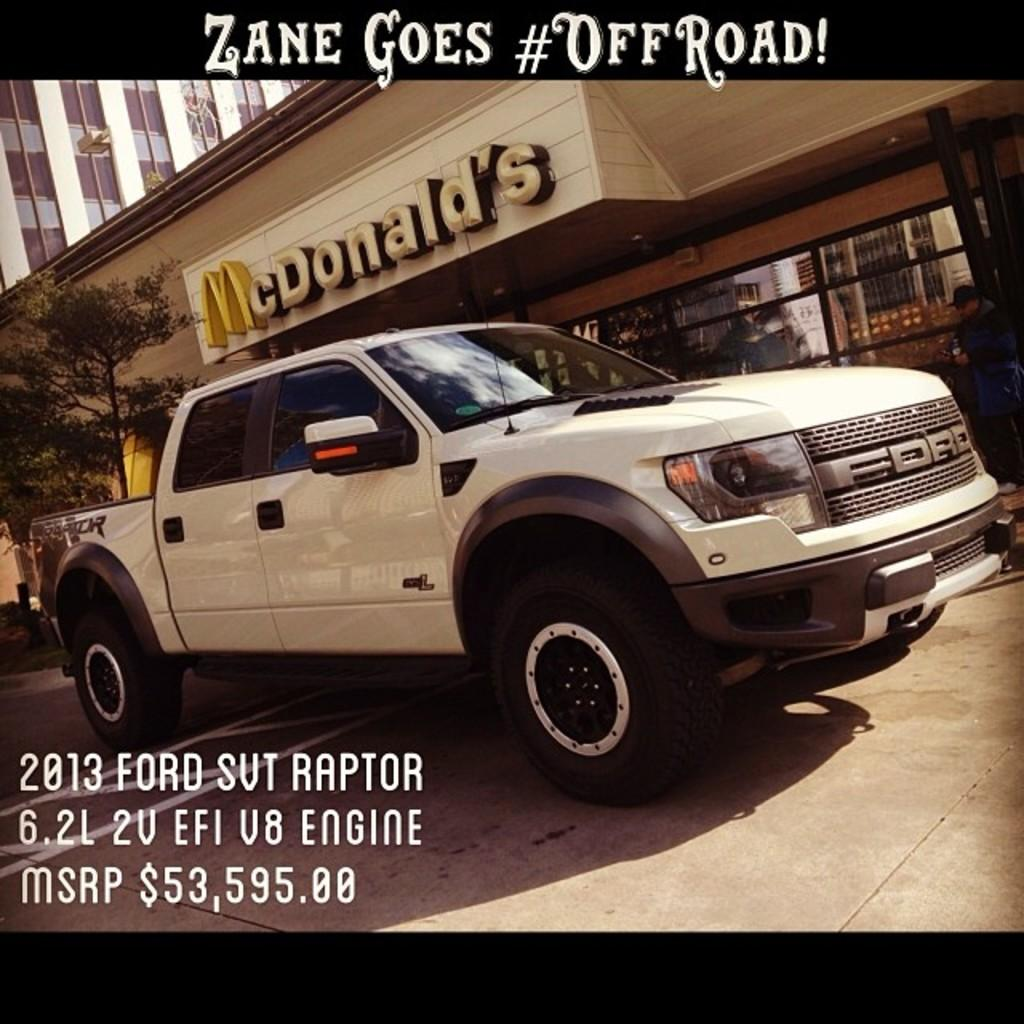What is the main subject in the middle of the image? There is a vehicle in the middle of the image. What can be seen in the background of the image? There are trees and buildings in the background of the image. Where is the text located in the image? There is text at the top and bottom of the image. What type of underwear is hanging on the side of the vehicle in the image? There is no underwear present in the image, and no items are hanging on the side of the vehicle. 